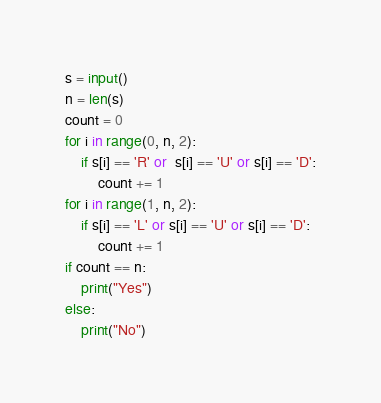<code> <loc_0><loc_0><loc_500><loc_500><_Python_>s = input()
n = len(s)
count = 0
for i in range(0, n, 2):
    if s[i] == 'R' or  s[i] == 'U' or s[i] == 'D':
        count += 1
for i in range(1, n, 2):
    if s[i] == 'L' or s[i] == 'U' or s[i] == 'D':
        count += 1
if count == n:
    print("Yes")
else:
    print("No")</code> 